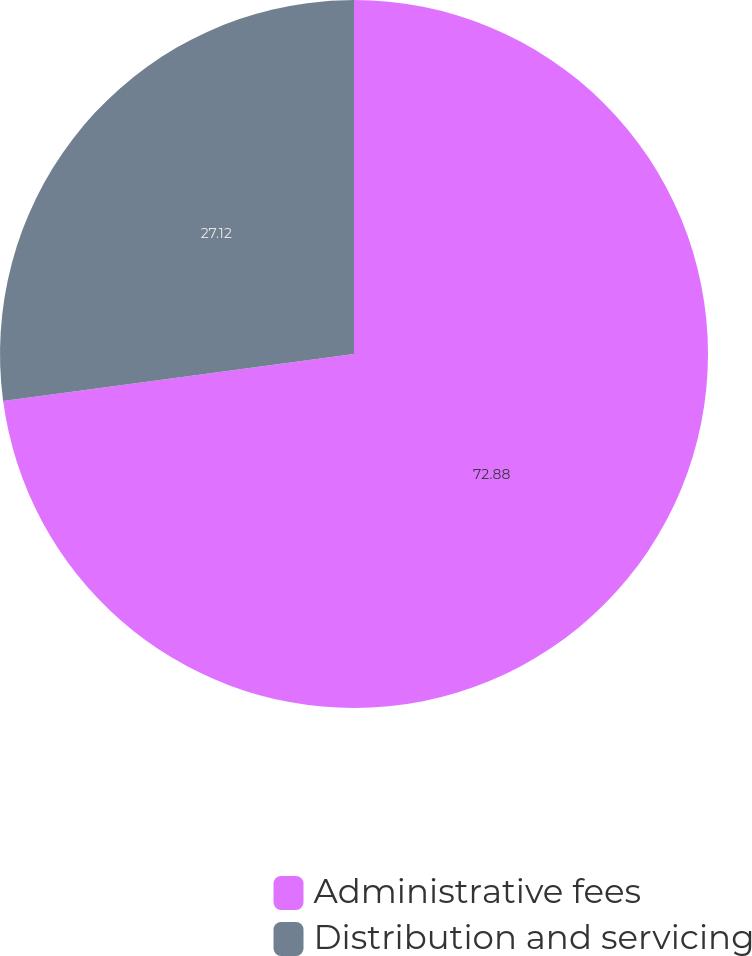<chart> <loc_0><loc_0><loc_500><loc_500><pie_chart><fcel>Administrative fees<fcel>Distribution and servicing<nl><fcel>72.88%<fcel>27.12%<nl></chart> 